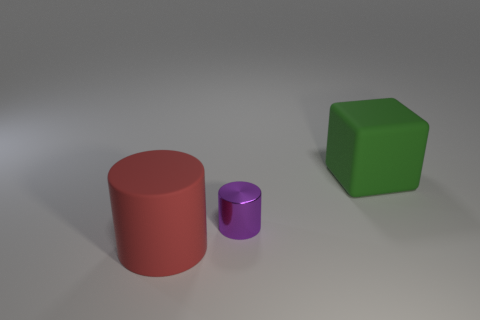Add 2 red cylinders. How many objects exist? 5 Subtract 2 cylinders. How many cylinders are left? 0 Subtract all cylinders. How many objects are left? 1 Add 2 large green cubes. How many large green cubes exist? 3 Subtract all purple cylinders. How many cylinders are left? 1 Subtract 0 purple spheres. How many objects are left? 3 Subtract all red blocks. Subtract all green cylinders. How many blocks are left? 1 Subtract all purple cubes. How many red cylinders are left? 1 Subtract all tiny purple rubber objects. Subtract all rubber objects. How many objects are left? 1 Add 3 big red objects. How many big red objects are left? 4 